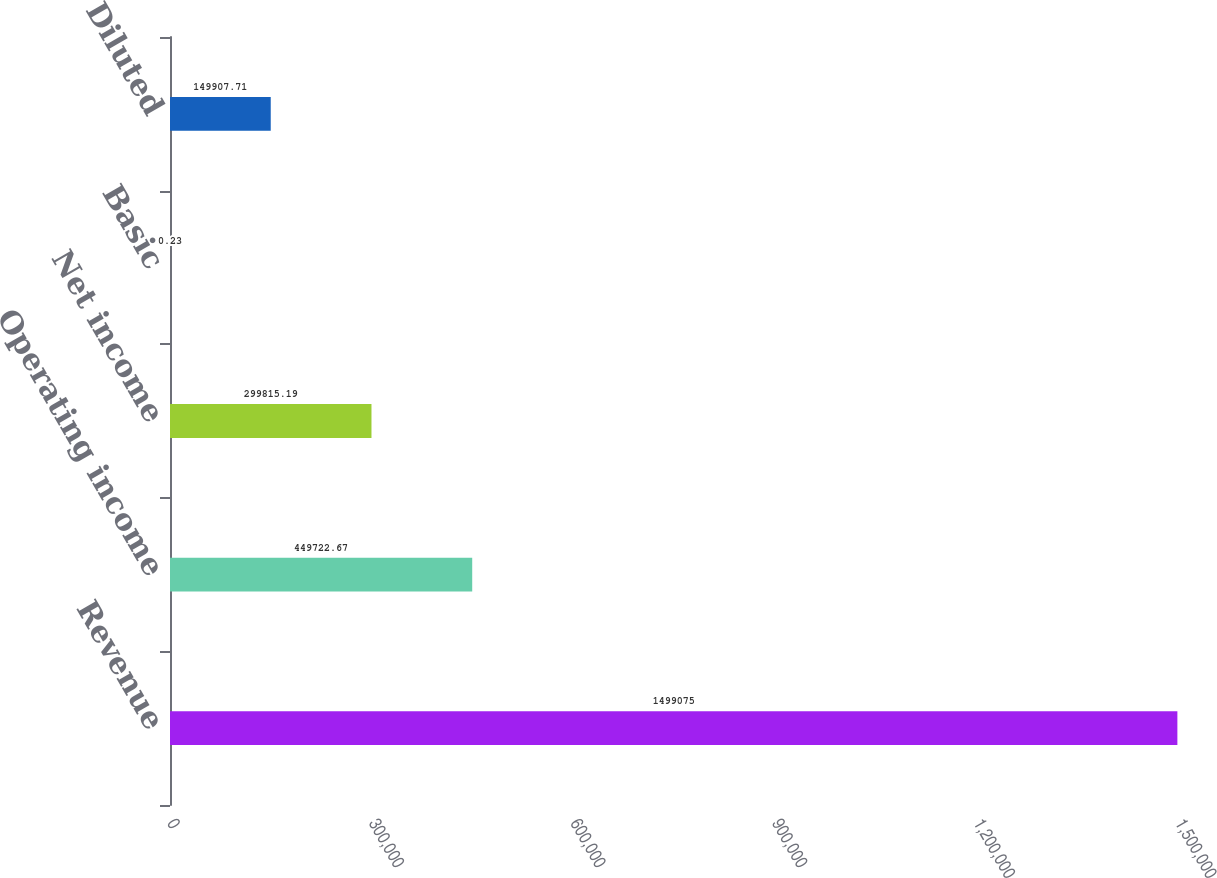<chart> <loc_0><loc_0><loc_500><loc_500><bar_chart><fcel>Revenue<fcel>Operating income<fcel>Net income<fcel>Basic<fcel>Diluted<nl><fcel>1.49908e+06<fcel>449723<fcel>299815<fcel>0.23<fcel>149908<nl></chart> 